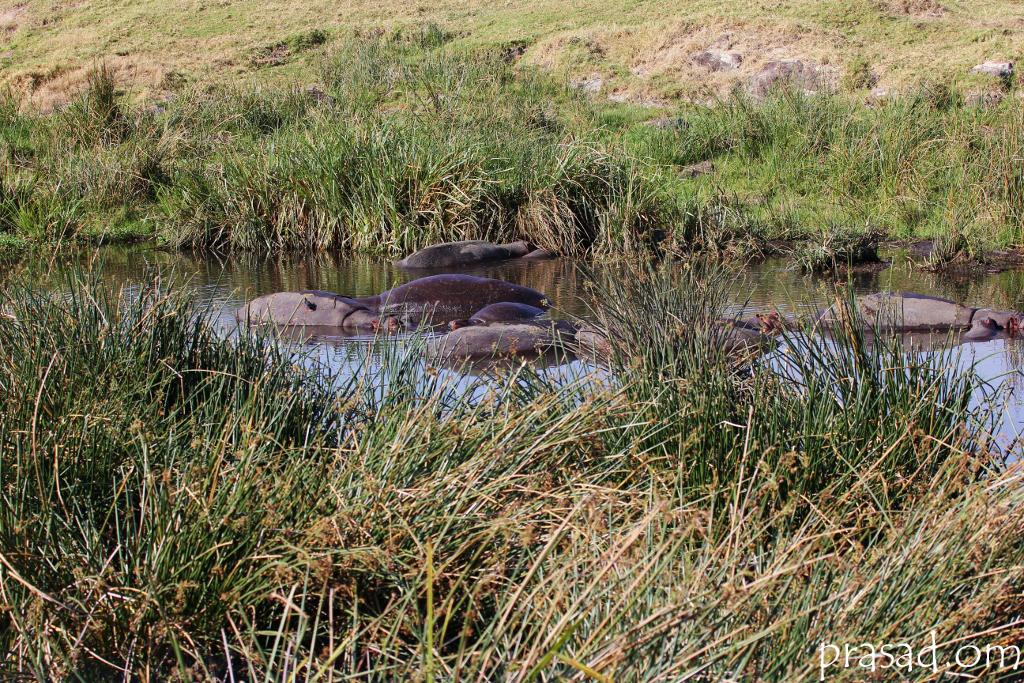What type of animals can be seen in the image? There are animals in the water. What type of vegetation is visible in the image? There is grass visible in the image. What type of frame is around the animals in the image? There is no frame around the animals in the image; it is a photograph or illustration of the animals in their natural environment. 